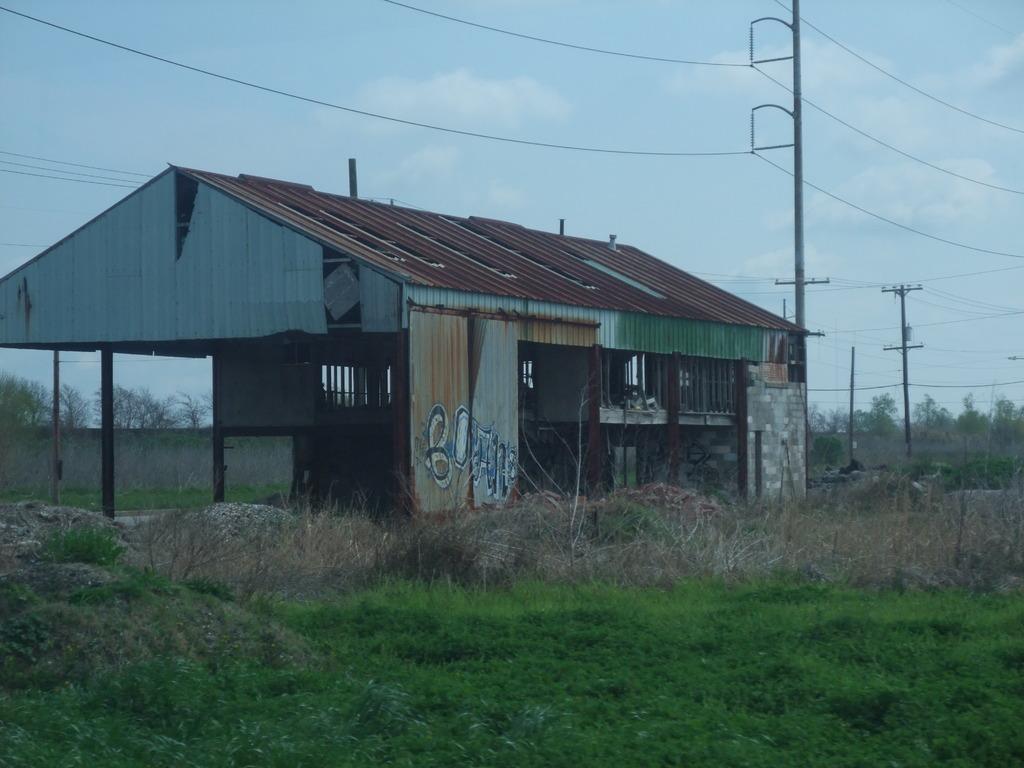Could you give a brief overview of what you see in this image? In this picture I can see a shed and also I can see some grass, trees and some poles. 